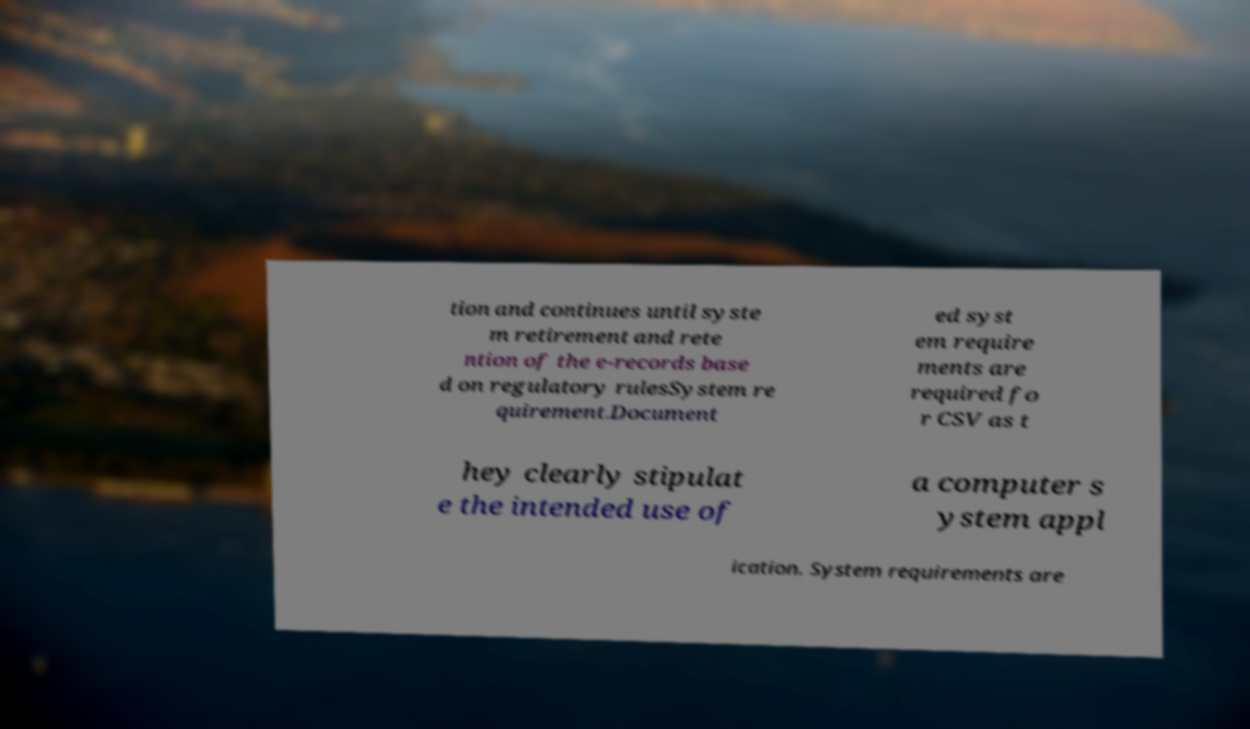Could you assist in decoding the text presented in this image and type it out clearly? tion and continues until syste m retirement and rete ntion of the e-records base d on regulatory rulesSystem re quirement.Document ed syst em require ments are required fo r CSV as t hey clearly stipulat e the intended use of a computer s ystem appl ication. System requirements are 